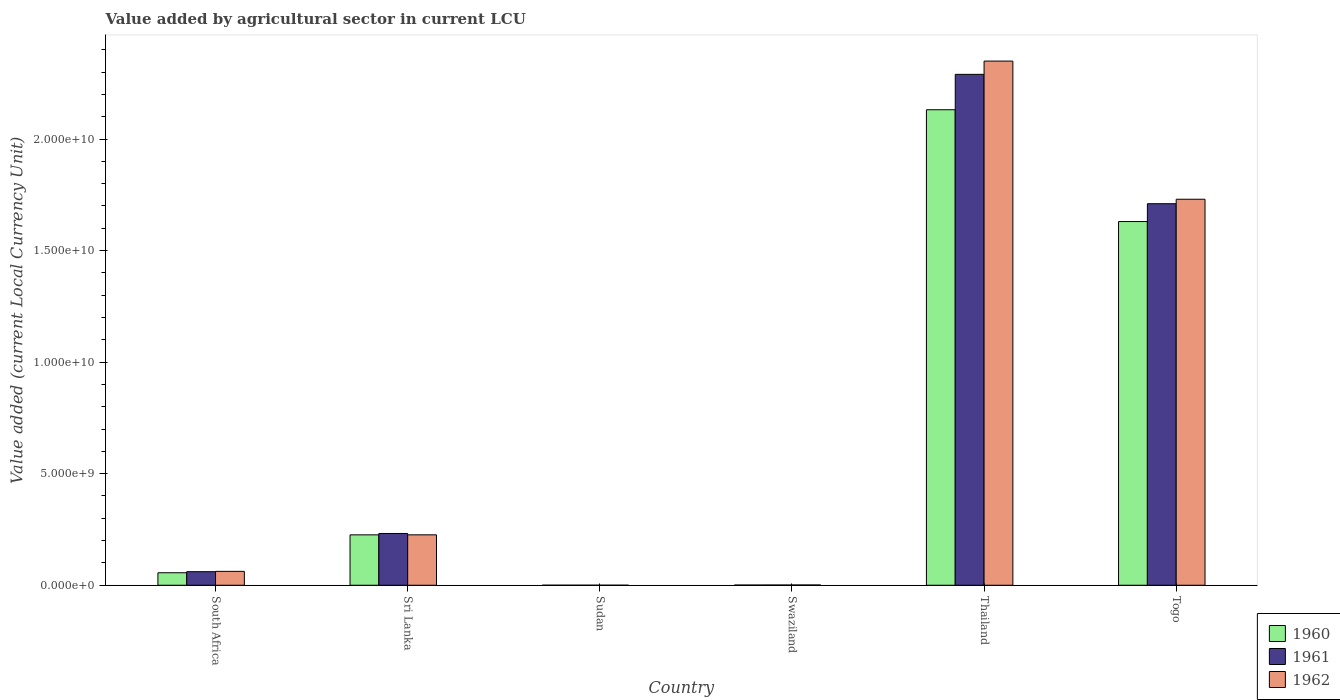How many different coloured bars are there?
Offer a very short reply. 3. Are the number of bars on each tick of the X-axis equal?
Your response must be concise. Yes. How many bars are there on the 2nd tick from the left?
Provide a succinct answer. 3. How many bars are there on the 6th tick from the right?
Provide a succinct answer. 3. What is the label of the 2nd group of bars from the left?
Give a very brief answer. Sri Lanka. What is the value added by agricultural sector in 1962 in Togo?
Offer a very short reply. 1.73e+1. Across all countries, what is the maximum value added by agricultural sector in 1962?
Your answer should be very brief. 2.35e+1. Across all countries, what is the minimum value added by agricultural sector in 1961?
Your answer should be compact. 2.19e+05. In which country was the value added by agricultural sector in 1960 maximum?
Offer a very short reply. Thailand. In which country was the value added by agricultural sector in 1961 minimum?
Your response must be concise. Sudan. What is the total value added by agricultural sector in 1962 in the graph?
Make the answer very short. 4.37e+1. What is the difference between the value added by agricultural sector in 1961 in Swaziland and that in Thailand?
Keep it short and to the point. -2.29e+1. What is the difference between the value added by agricultural sector in 1962 in South Africa and the value added by agricultural sector in 1960 in Togo?
Offer a very short reply. -1.57e+1. What is the average value added by agricultural sector in 1961 per country?
Your response must be concise. 7.16e+09. What is the difference between the value added by agricultural sector of/in 1960 and value added by agricultural sector of/in 1962 in Sudan?
Make the answer very short. -2.90e+04. In how many countries, is the value added by agricultural sector in 1960 greater than 6000000000 LCU?
Your answer should be very brief. 2. What is the ratio of the value added by agricultural sector in 1962 in Thailand to that in Togo?
Keep it short and to the point. 1.36. Is the value added by agricultural sector in 1961 in Swaziland less than that in Thailand?
Keep it short and to the point. Yes. What is the difference between the highest and the second highest value added by agricultural sector in 1962?
Offer a terse response. -6.19e+09. What is the difference between the highest and the lowest value added by agricultural sector in 1961?
Keep it short and to the point. 2.29e+1. What does the 2nd bar from the right in Sri Lanka represents?
Your answer should be compact. 1961. Is it the case that in every country, the sum of the value added by agricultural sector in 1961 and value added by agricultural sector in 1960 is greater than the value added by agricultural sector in 1962?
Your response must be concise. Yes. How many bars are there?
Make the answer very short. 18. How many countries are there in the graph?
Your answer should be compact. 6. Are the values on the major ticks of Y-axis written in scientific E-notation?
Ensure brevity in your answer.  Yes. Does the graph contain any zero values?
Ensure brevity in your answer.  No. Does the graph contain grids?
Provide a short and direct response. No. How many legend labels are there?
Your response must be concise. 3. How are the legend labels stacked?
Make the answer very short. Vertical. What is the title of the graph?
Make the answer very short. Value added by agricultural sector in current LCU. Does "1994" appear as one of the legend labels in the graph?
Keep it short and to the point. No. What is the label or title of the Y-axis?
Provide a succinct answer. Value added (current Local Currency Unit). What is the Value added (current Local Currency Unit) of 1960 in South Africa?
Provide a short and direct response. 5.59e+08. What is the Value added (current Local Currency Unit) of 1961 in South Africa?
Ensure brevity in your answer.  6.08e+08. What is the Value added (current Local Currency Unit) in 1962 in South Africa?
Offer a terse response. 6.22e+08. What is the Value added (current Local Currency Unit) of 1960 in Sri Lanka?
Provide a short and direct response. 2.26e+09. What is the Value added (current Local Currency Unit) of 1961 in Sri Lanka?
Give a very brief answer. 2.32e+09. What is the Value added (current Local Currency Unit) of 1962 in Sri Lanka?
Ensure brevity in your answer.  2.26e+09. What is the Value added (current Local Currency Unit) in 1960 in Sudan?
Offer a very short reply. 2.02e+05. What is the Value added (current Local Currency Unit) in 1961 in Sudan?
Provide a short and direct response. 2.19e+05. What is the Value added (current Local Currency Unit) of 1962 in Sudan?
Your response must be concise. 2.31e+05. What is the Value added (current Local Currency Unit) of 1960 in Swaziland?
Offer a very short reply. 7.90e+06. What is the Value added (current Local Currency Unit) of 1961 in Swaziland?
Your answer should be very brief. 9.30e+06. What is the Value added (current Local Currency Unit) of 1962 in Swaziland?
Make the answer very short. 1.14e+07. What is the Value added (current Local Currency Unit) in 1960 in Thailand?
Your response must be concise. 2.13e+1. What is the Value added (current Local Currency Unit) of 1961 in Thailand?
Make the answer very short. 2.29e+1. What is the Value added (current Local Currency Unit) in 1962 in Thailand?
Your answer should be compact. 2.35e+1. What is the Value added (current Local Currency Unit) of 1960 in Togo?
Ensure brevity in your answer.  1.63e+1. What is the Value added (current Local Currency Unit) in 1961 in Togo?
Your answer should be compact. 1.71e+1. What is the Value added (current Local Currency Unit) of 1962 in Togo?
Your answer should be compact. 1.73e+1. Across all countries, what is the maximum Value added (current Local Currency Unit) in 1960?
Provide a short and direct response. 2.13e+1. Across all countries, what is the maximum Value added (current Local Currency Unit) in 1961?
Ensure brevity in your answer.  2.29e+1. Across all countries, what is the maximum Value added (current Local Currency Unit) in 1962?
Keep it short and to the point. 2.35e+1. Across all countries, what is the minimum Value added (current Local Currency Unit) of 1960?
Keep it short and to the point. 2.02e+05. Across all countries, what is the minimum Value added (current Local Currency Unit) of 1961?
Ensure brevity in your answer.  2.19e+05. Across all countries, what is the minimum Value added (current Local Currency Unit) in 1962?
Your answer should be compact. 2.31e+05. What is the total Value added (current Local Currency Unit) in 1960 in the graph?
Provide a succinct answer. 4.04e+1. What is the total Value added (current Local Currency Unit) in 1961 in the graph?
Offer a terse response. 4.29e+1. What is the total Value added (current Local Currency Unit) of 1962 in the graph?
Provide a succinct answer. 4.37e+1. What is the difference between the Value added (current Local Currency Unit) in 1960 in South Africa and that in Sri Lanka?
Make the answer very short. -1.70e+09. What is the difference between the Value added (current Local Currency Unit) of 1961 in South Africa and that in Sri Lanka?
Offer a very short reply. -1.71e+09. What is the difference between the Value added (current Local Currency Unit) in 1962 in South Africa and that in Sri Lanka?
Your answer should be compact. -1.64e+09. What is the difference between the Value added (current Local Currency Unit) in 1960 in South Africa and that in Sudan?
Make the answer very short. 5.59e+08. What is the difference between the Value added (current Local Currency Unit) in 1961 in South Africa and that in Sudan?
Make the answer very short. 6.07e+08. What is the difference between the Value added (current Local Currency Unit) in 1962 in South Africa and that in Sudan?
Give a very brief answer. 6.21e+08. What is the difference between the Value added (current Local Currency Unit) in 1960 in South Africa and that in Swaziland?
Offer a very short reply. 5.51e+08. What is the difference between the Value added (current Local Currency Unit) of 1961 in South Africa and that in Swaziland?
Provide a succinct answer. 5.98e+08. What is the difference between the Value added (current Local Currency Unit) in 1962 in South Africa and that in Swaziland?
Give a very brief answer. 6.10e+08. What is the difference between the Value added (current Local Currency Unit) of 1960 in South Africa and that in Thailand?
Keep it short and to the point. -2.08e+1. What is the difference between the Value added (current Local Currency Unit) of 1961 in South Africa and that in Thailand?
Provide a succinct answer. -2.23e+1. What is the difference between the Value added (current Local Currency Unit) in 1962 in South Africa and that in Thailand?
Your answer should be very brief. -2.29e+1. What is the difference between the Value added (current Local Currency Unit) in 1960 in South Africa and that in Togo?
Your answer should be very brief. -1.57e+1. What is the difference between the Value added (current Local Currency Unit) in 1961 in South Africa and that in Togo?
Your answer should be very brief. -1.65e+1. What is the difference between the Value added (current Local Currency Unit) in 1962 in South Africa and that in Togo?
Offer a very short reply. -1.67e+1. What is the difference between the Value added (current Local Currency Unit) in 1960 in Sri Lanka and that in Sudan?
Your response must be concise. 2.26e+09. What is the difference between the Value added (current Local Currency Unit) of 1961 in Sri Lanka and that in Sudan?
Your answer should be compact. 2.32e+09. What is the difference between the Value added (current Local Currency Unit) of 1962 in Sri Lanka and that in Sudan?
Your answer should be compact. 2.26e+09. What is the difference between the Value added (current Local Currency Unit) in 1960 in Sri Lanka and that in Swaziland?
Provide a short and direct response. 2.25e+09. What is the difference between the Value added (current Local Currency Unit) in 1961 in Sri Lanka and that in Swaziland?
Offer a very short reply. 2.31e+09. What is the difference between the Value added (current Local Currency Unit) in 1962 in Sri Lanka and that in Swaziland?
Keep it short and to the point. 2.25e+09. What is the difference between the Value added (current Local Currency Unit) of 1960 in Sri Lanka and that in Thailand?
Ensure brevity in your answer.  -1.91e+1. What is the difference between the Value added (current Local Currency Unit) in 1961 in Sri Lanka and that in Thailand?
Keep it short and to the point. -2.06e+1. What is the difference between the Value added (current Local Currency Unit) of 1962 in Sri Lanka and that in Thailand?
Give a very brief answer. -2.12e+1. What is the difference between the Value added (current Local Currency Unit) in 1960 in Sri Lanka and that in Togo?
Your answer should be very brief. -1.40e+1. What is the difference between the Value added (current Local Currency Unit) of 1961 in Sri Lanka and that in Togo?
Offer a terse response. -1.48e+1. What is the difference between the Value added (current Local Currency Unit) of 1962 in Sri Lanka and that in Togo?
Your answer should be very brief. -1.50e+1. What is the difference between the Value added (current Local Currency Unit) of 1960 in Sudan and that in Swaziland?
Your answer should be compact. -7.70e+06. What is the difference between the Value added (current Local Currency Unit) of 1961 in Sudan and that in Swaziland?
Your answer should be compact. -9.08e+06. What is the difference between the Value added (current Local Currency Unit) of 1962 in Sudan and that in Swaziland?
Your answer should be compact. -1.12e+07. What is the difference between the Value added (current Local Currency Unit) in 1960 in Sudan and that in Thailand?
Offer a terse response. -2.13e+1. What is the difference between the Value added (current Local Currency Unit) in 1961 in Sudan and that in Thailand?
Your answer should be compact. -2.29e+1. What is the difference between the Value added (current Local Currency Unit) of 1962 in Sudan and that in Thailand?
Provide a short and direct response. -2.35e+1. What is the difference between the Value added (current Local Currency Unit) of 1960 in Sudan and that in Togo?
Your answer should be very brief. -1.63e+1. What is the difference between the Value added (current Local Currency Unit) in 1961 in Sudan and that in Togo?
Provide a short and direct response. -1.71e+1. What is the difference between the Value added (current Local Currency Unit) of 1962 in Sudan and that in Togo?
Provide a succinct answer. -1.73e+1. What is the difference between the Value added (current Local Currency Unit) in 1960 in Swaziland and that in Thailand?
Offer a very short reply. -2.13e+1. What is the difference between the Value added (current Local Currency Unit) in 1961 in Swaziland and that in Thailand?
Your answer should be very brief. -2.29e+1. What is the difference between the Value added (current Local Currency Unit) in 1962 in Swaziland and that in Thailand?
Make the answer very short. -2.35e+1. What is the difference between the Value added (current Local Currency Unit) of 1960 in Swaziland and that in Togo?
Your answer should be very brief. -1.63e+1. What is the difference between the Value added (current Local Currency Unit) in 1961 in Swaziland and that in Togo?
Provide a short and direct response. -1.71e+1. What is the difference between the Value added (current Local Currency Unit) in 1962 in Swaziland and that in Togo?
Give a very brief answer. -1.73e+1. What is the difference between the Value added (current Local Currency Unit) in 1960 in Thailand and that in Togo?
Offer a terse response. 5.01e+09. What is the difference between the Value added (current Local Currency Unit) in 1961 in Thailand and that in Togo?
Ensure brevity in your answer.  5.80e+09. What is the difference between the Value added (current Local Currency Unit) in 1962 in Thailand and that in Togo?
Your answer should be compact. 6.19e+09. What is the difference between the Value added (current Local Currency Unit) in 1960 in South Africa and the Value added (current Local Currency Unit) in 1961 in Sri Lanka?
Keep it short and to the point. -1.76e+09. What is the difference between the Value added (current Local Currency Unit) of 1960 in South Africa and the Value added (current Local Currency Unit) of 1962 in Sri Lanka?
Provide a short and direct response. -1.70e+09. What is the difference between the Value added (current Local Currency Unit) in 1961 in South Africa and the Value added (current Local Currency Unit) in 1962 in Sri Lanka?
Make the answer very short. -1.65e+09. What is the difference between the Value added (current Local Currency Unit) in 1960 in South Africa and the Value added (current Local Currency Unit) in 1961 in Sudan?
Make the answer very short. 5.59e+08. What is the difference between the Value added (current Local Currency Unit) of 1960 in South Africa and the Value added (current Local Currency Unit) of 1962 in Sudan?
Make the answer very short. 5.59e+08. What is the difference between the Value added (current Local Currency Unit) of 1961 in South Africa and the Value added (current Local Currency Unit) of 1962 in Sudan?
Make the answer very short. 6.07e+08. What is the difference between the Value added (current Local Currency Unit) in 1960 in South Africa and the Value added (current Local Currency Unit) in 1961 in Swaziland?
Your answer should be very brief. 5.50e+08. What is the difference between the Value added (current Local Currency Unit) of 1960 in South Africa and the Value added (current Local Currency Unit) of 1962 in Swaziland?
Provide a short and direct response. 5.48e+08. What is the difference between the Value added (current Local Currency Unit) of 1961 in South Africa and the Value added (current Local Currency Unit) of 1962 in Swaziland?
Make the answer very short. 5.96e+08. What is the difference between the Value added (current Local Currency Unit) of 1960 in South Africa and the Value added (current Local Currency Unit) of 1961 in Thailand?
Ensure brevity in your answer.  -2.23e+1. What is the difference between the Value added (current Local Currency Unit) in 1960 in South Africa and the Value added (current Local Currency Unit) in 1962 in Thailand?
Your answer should be very brief. -2.29e+1. What is the difference between the Value added (current Local Currency Unit) in 1961 in South Africa and the Value added (current Local Currency Unit) in 1962 in Thailand?
Make the answer very short. -2.29e+1. What is the difference between the Value added (current Local Currency Unit) in 1960 in South Africa and the Value added (current Local Currency Unit) in 1961 in Togo?
Provide a succinct answer. -1.65e+1. What is the difference between the Value added (current Local Currency Unit) of 1960 in South Africa and the Value added (current Local Currency Unit) of 1962 in Togo?
Make the answer very short. -1.67e+1. What is the difference between the Value added (current Local Currency Unit) of 1961 in South Africa and the Value added (current Local Currency Unit) of 1962 in Togo?
Offer a terse response. -1.67e+1. What is the difference between the Value added (current Local Currency Unit) of 1960 in Sri Lanka and the Value added (current Local Currency Unit) of 1961 in Sudan?
Your answer should be compact. 2.26e+09. What is the difference between the Value added (current Local Currency Unit) of 1960 in Sri Lanka and the Value added (current Local Currency Unit) of 1962 in Sudan?
Provide a succinct answer. 2.26e+09. What is the difference between the Value added (current Local Currency Unit) of 1961 in Sri Lanka and the Value added (current Local Currency Unit) of 1962 in Sudan?
Offer a terse response. 2.32e+09. What is the difference between the Value added (current Local Currency Unit) of 1960 in Sri Lanka and the Value added (current Local Currency Unit) of 1961 in Swaziland?
Give a very brief answer. 2.25e+09. What is the difference between the Value added (current Local Currency Unit) of 1960 in Sri Lanka and the Value added (current Local Currency Unit) of 1962 in Swaziland?
Provide a succinct answer. 2.25e+09. What is the difference between the Value added (current Local Currency Unit) of 1961 in Sri Lanka and the Value added (current Local Currency Unit) of 1962 in Swaziland?
Your response must be concise. 2.31e+09. What is the difference between the Value added (current Local Currency Unit) in 1960 in Sri Lanka and the Value added (current Local Currency Unit) in 1961 in Thailand?
Your answer should be compact. -2.06e+1. What is the difference between the Value added (current Local Currency Unit) in 1960 in Sri Lanka and the Value added (current Local Currency Unit) in 1962 in Thailand?
Give a very brief answer. -2.12e+1. What is the difference between the Value added (current Local Currency Unit) in 1961 in Sri Lanka and the Value added (current Local Currency Unit) in 1962 in Thailand?
Make the answer very short. -2.12e+1. What is the difference between the Value added (current Local Currency Unit) in 1960 in Sri Lanka and the Value added (current Local Currency Unit) in 1961 in Togo?
Provide a short and direct response. -1.48e+1. What is the difference between the Value added (current Local Currency Unit) in 1960 in Sri Lanka and the Value added (current Local Currency Unit) in 1962 in Togo?
Your answer should be very brief. -1.50e+1. What is the difference between the Value added (current Local Currency Unit) in 1961 in Sri Lanka and the Value added (current Local Currency Unit) in 1962 in Togo?
Your response must be concise. -1.50e+1. What is the difference between the Value added (current Local Currency Unit) of 1960 in Sudan and the Value added (current Local Currency Unit) of 1961 in Swaziland?
Your answer should be very brief. -9.10e+06. What is the difference between the Value added (current Local Currency Unit) in 1960 in Sudan and the Value added (current Local Currency Unit) in 1962 in Swaziland?
Provide a succinct answer. -1.12e+07. What is the difference between the Value added (current Local Currency Unit) of 1961 in Sudan and the Value added (current Local Currency Unit) of 1962 in Swaziland?
Give a very brief answer. -1.12e+07. What is the difference between the Value added (current Local Currency Unit) of 1960 in Sudan and the Value added (current Local Currency Unit) of 1961 in Thailand?
Keep it short and to the point. -2.29e+1. What is the difference between the Value added (current Local Currency Unit) of 1960 in Sudan and the Value added (current Local Currency Unit) of 1962 in Thailand?
Offer a terse response. -2.35e+1. What is the difference between the Value added (current Local Currency Unit) of 1961 in Sudan and the Value added (current Local Currency Unit) of 1962 in Thailand?
Your response must be concise. -2.35e+1. What is the difference between the Value added (current Local Currency Unit) in 1960 in Sudan and the Value added (current Local Currency Unit) in 1961 in Togo?
Give a very brief answer. -1.71e+1. What is the difference between the Value added (current Local Currency Unit) in 1960 in Sudan and the Value added (current Local Currency Unit) in 1962 in Togo?
Your answer should be compact. -1.73e+1. What is the difference between the Value added (current Local Currency Unit) of 1961 in Sudan and the Value added (current Local Currency Unit) of 1962 in Togo?
Provide a succinct answer. -1.73e+1. What is the difference between the Value added (current Local Currency Unit) of 1960 in Swaziland and the Value added (current Local Currency Unit) of 1961 in Thailand?
Your response must be concise. -2.29e+1. What is the difference between the Value added (current Local Currency Unit) in 1960 in Swaziland and the Value added (current Local Currency Unit) in 1962 in Thailand?
Make the answer very short. -2.35e+1. What is the difference between the Value added (current Local Currency Unit) in 1961 in Swaziland and the Value added (current Local Currency Unit) in 1962 in Thailand?
Your answer should be compact. -2.35e+1. What is the difference between the Value added (current Local Currency Unit) in 1960 in Swaziland and the Value added (current Local Currency Unit) in 1961 in Togo?
Provide a short and direct response. -1.71e+1. What is the difference between the Value added (current Local Currency Unit) of 1960 in Swaziland and the Value added (current Local Currency Unit) of 1962 in Togo?
Your answer should be very brief. -1.73e+1. What is the difference between the Value added (current Local Currency Unit) in 1961 in Swaziland and the Value added (current Local Currency Unit) in 1962 in Togo?
Your answer should be compact. -1.73e+1. What is the difference between the Value added (current Local Currency Unit) in 1960 in Thailand and the Value added (current Local Currency Unit) in 1961 in Togo?
Give a very brief answer. 4.21e+09. What is the difference between the Value added (current Local Currency Unit) in 1960 in Thailand and the Value added (current Local Currency Unit) in 1962 in Togo?
Your answer should be compact. 4.01e+09. What is the difference between the Value added (current Local Currency Unit) in 1961 in Thailand and the Value added (current Local Currency Unit) in 1962 in Togo?
Provide a succinct answer. 5.60e+09. What is the average Value added (current Local Currency Unit) of 1960 per country?
Keep it short and to the point. 6.74e+09. What is the average Value added (current Local Currency Unit) in 1961 per country?
Your answer should be compact. 7.16e+09. What is the average Value added (current Local Currency Unit) in 1962 per country?
Make the answer very short. 7.28e+09. What is the difference between the Value added (current Local Currency Unit) of 1960 and Value added (current Local Currency Unit) of 1961 in South Africa?
Keep it short and to the point. -4.85e+07. What is the difference between the Value added (current Local Currency Unit) of 1960 and Value added (current Local Currency Unit) of 1962 in South Africa?
Keep it short and to the point. -6.25e+07. What is the difference between the Value added (current Local Currency Unit) in 1961 and Value added (current Local Currency Unit) in 1962 in South Africa?
Offer a terse response. -1.40e+07. What is the difference between the Value added (current Local Currency Unit) of 1960 and Value added (current Local Currency Unit) of 1961 in Sri Lanka?
Your answer should be compact. -6.20e+07. What is the difference between the Value added (current Local Currency Unit) of 1960 and Value added (current Local Currency Unit) of 1962 in Sri Lanka?
Provide a short and direct response. -1.00e+06. What is the difference between the Value added (current Local Currency Unit) in 1961 and Value added (current Local Currency Unit) in 1962 in Sri Lanka?
Your answer should be compact. 6.10e+07. What is the difference between the Value added (current Local Currency Unit) of 1960 and Value added (current Local Currency Unit) of 1961 in Sudan?
Provide a succinct answer. -1.76e+04. What is the difference between the Value added (current Local Currency Unit) in 1960 and Value added (current Local Currency Unit) in 1962 in Sudan?
Offer a terse response. -2.90e+04. What is the difference between the Value added (current Local Currency Unit) of 1961 and Value added (current Local Currency Unit) of 1962 in Sudan?
Give a very brief answer. -1.14e+04. What is the difference between the Value added (current Local Currency Unit) of 1960 and Value added (current Local Currency Unit) of 1961 in Swaziland?
Keep it short and to the point. -1.40e+06. What is the difference between the Value added (current Local Currency Unit) in 1960 and Value added (current Local Currency Unit) in 1962 in Swaziland?
Your response must be concise. -3.50e+06. What is the difference between the Value added (current Local Currency Unit) in 1961 and Value added (current Local Currency Unit) in 1962 in Swaziland?
Offer a terse response. -2.10e+06. What is the difference between the Value added (current Local Currency Unit) in 1960 and Value added (current Local Currency Unit) in 1961 in Thailand?
Your answer should be very brief. -1.59e+09. What is the difference between the Value added (current Local Currency Unit) in 1960 and Value added (current Local Currency Unit) in 1962 in Thailand?
Your answer should be very brief. -2.18e+09. What is the difference between the Value added (current Local Currency Unit) in 1961 and Value added (current Local Currency Unit) in 1962 in Thailand?
Provide a succinct answer. -5.95e+08. What is the difference between the Value added (current Local Currency Unit) in 1960 and Value added (current Local Currency Unit) in 1961 in Togo?
Offer a terse response. -8.00e+08. What is the difference between the Value added (current Local Currency Unit) of 1960 and Value added (current Local Currency Unit) of 1962 in Togo?
Provide a short and direct response. -1.00e+09. What is the difference between the Value added (current Local Currency Unit) in 1961 and Value added (current Local Currency Unit) in 1962 in Togo?
Provide a succinct answer. -2.00e+08. What is the ratio of the Value added (current Local Currency Unit) of 1960 in South Africa to that in Sri Lanka?
Give a very brief answer. 0.25. What is the ratio of the Value added (current Local Currency Unit) of 1961 in South Africa to that in Sri Lanka?
Ensure brevity in your answer.  0.26. What is the ratio of the Value added (current Local Currency Unit) of 1962 in South Africa to that in Sri Lanka?
Your answer should be very brief. 0.28. What is the ratio of the Value added (current Local Currency Unit) in 1960 in South Africa to that in Sudan?
Ensure brevity in your answer.  2772.04. What is the ratio of the Value added (current Local Currency Unit) of 1961 in South Africa to that in Sudan?
Give a very brief answer. 2770.9. What is the ratio of the Value added (current Local Currency Unit) of 1962 in South Africa to that in Sudan?
Ensure brevity in your answer.  2694.67. What is the ratio of the Value added (current Local Currency Unit) in 1960 in South Africa to that in Swaziland?
Provide a short and direct response. 70.77. What is the ratio of the Value added (current Local Currency Unit) in 1961 in South Africa to that in Swaziland?
Provide a short and direct response. 65.34. What is the ratio of the Value added (current Local Currency Unit) in 1962 in South Africa to that in Swaziland?
Offer a terse response. 54.53. What is the ratio of the Value added (current Local Currency Unit) in 1960 in South Africa to that in Thailand?
Your answer should be compact. 0.03. What is the ratio of the Value added (current Local Currency Unit) of 1961 in South Africa to that in Thailand?
Ensure brevity in your answer.  0.03. What is the ratio of the Value added (current Local Currency Unit) of 1962 in South Africa to that in Thailand?
Offer a very short reply. 0.03. What is the ratio of the Value added (current Local Currency Unit) in 1960 in South Africa to that in Togo?
Offer a very short reply. 0.03. What is the ratio of the Value added (current Local Currency Unit) of 1961 in South Africa to that in Togo?
Offer a very short reply. 0.04. What is the ratio of the Value added (current Local Currency Unit) of 1962 in South Africa to that in Togo?
Offer a terse response. 0.04. What is the ratio of the Value added (current Local Currency Unit) in 1960 in Sri Lanka to that in Sudan?
Provide a succinct answer. 1.12e+04. What is the ratio of the Value added (current Local Currency Unit) in 1961 in Sri Lanka to that in Sudan?
Make the answer very short. 1.06e+04. What is the ratio of the Value added (current Local Currency Unit) of 1962 in Sri Lanka to that in Sudan?
Keep it short and to the point. 9791.94. What is the ratio of the Value added (current Local Currency Unit) of 1960 in Sri Lanka to that in Swaziland?
Offer a terse response. 285.82. What is the ratio of the Value added (current Local Currency Unit) in 1961 in Sri Lanka to that in Swaziland?
Your answer should be compact. 249.46. What is the ratio of the Value added (current Local Currency Unit) of 1962 in Sri Lanka to that in Swaziland?
Keep it short and to the point. 198.16. What is the ratio of the Value added (current Local Currency Unit) of 1960 in Sri Lanka to that in Thailand?
Your response must be concise. 0.11. What is the ratio of the Value added (current Local Currency Unit) in 1961 in Sri Lanka to that in Thailand?
Provide a succinct answer. 0.1. What is the ratio of the Value added (current Local Currency Unit) in 1962 in Sri Lanka to that in Thailand?
Your answer should be compact. 0.1. What is the ratio of the Value added (current Local Currency Unit) of 1960 in Sri Lanka to that in Togo?
Your answer should be compact. 0.14. What is the ratio of the Value added (current Local Currency Unit) in 1961 in Sri Lanka to that in Togo?
Give a very brief answer. 0.14. What is the ratio of the Value added (current Local Currency Unit) of 1962 in Sri Lanka to that in Togo?
Offer a very short reply. 0.13. What is the ratio of the Value added (current Local Currency Unit) of 1960 in Sudan to that in Swaziland?
Provide a succinct answer. 0.03. What is the ratio of the Value added (current Local Currency Unit) in 1961 in Sudan to that in Swaziland?
Ensure brevity in your answer.  0.02. What is the ratio of the Value added (current Local Currency Unit) in 1962 in Sudan to that in Swaziland?
Your answer should be compact. 0.02. What is the ratio of the Value added (current Local Currency Unit) of 1960 in Sudan to that in Thailand?
Provide a short and direct response. 0. What is the ratio of the Value added (current Local Currency Unit) in 1961 in Sudan to that in Thailand?
Offer a very short reply. 0. What is the ratio of the Value added (current Local Currency Unit) in 1960 in Sudan to that in Togo?
Keep it short and to the point. 0. What is the ratio of the Value added (current Local Currency Unit) of 1961 in Sudan to that in Togo?
Offer a very short reply. 0. What is the ratio of the Value added (current Local Currency Unit) of 1962 in Sudan to that in Togo?
Provide a succinct answer. 0. What is the ratio of the Value added (current Local Currency Unit) in 1962 in Swaziland to that in Thailand?
Provide a succinct answer. 0. What is the ratio of the Value added (current Local Currency Unit) of 1960 in Swaziland to that in Togo?
Offer a terse response. 0. What is the ratio of the Value added (current Local Currency Unit) in 1961 in Swaziland to that in Togo?
Make the answer very short. 0. What is the ratio of the Value added (current Local Currency Unit) in 1962 in Swaziland to that in Togo?
Ensure brevity in your answer.  0. What is the ratio of the Value added (current Local Currency Unit) in 1960 in Thailand to that in Togo?
Make the answer very short. 1.31. What is the ratio of the Value added (current Local Currency Unit) in 1961 in Thailand to that in Togo?
Offer a very short reply. 1.34. What is the ratio of the Value added (current Local Currency Unit) in 1962 in Thailand to that in Togo?
Your answer should be very brief. 1.36. What is the difference between the highest and the second highest Value added (current Local Currency Unit) in 1960?
Keep it short and to the point. 5.01e+09. What is the difference between the highest and the second highest Value added (current Local Currency Unit) in 1961?
Your response must be concise. 5.80e+09. What is the difference between the highest and the second highest Value added (current Local Currency Unit) of 1962?
Your answer should be very brief. 6.19e+09. What is the difference between the highest and the lowest Value added (current Local Currency Unit) of 1960?
Give a very brief answer. 2.13e+1. What is the difference between the highest and the lowest Value added (current Local Currency Unit) in 1961?
Offer a very short reply. 2.29e+1. What is the difference between the highest and the lowest Value added (current Local Currency Unit) of 1962?
Offer a very short reply. 2.35e+1. 